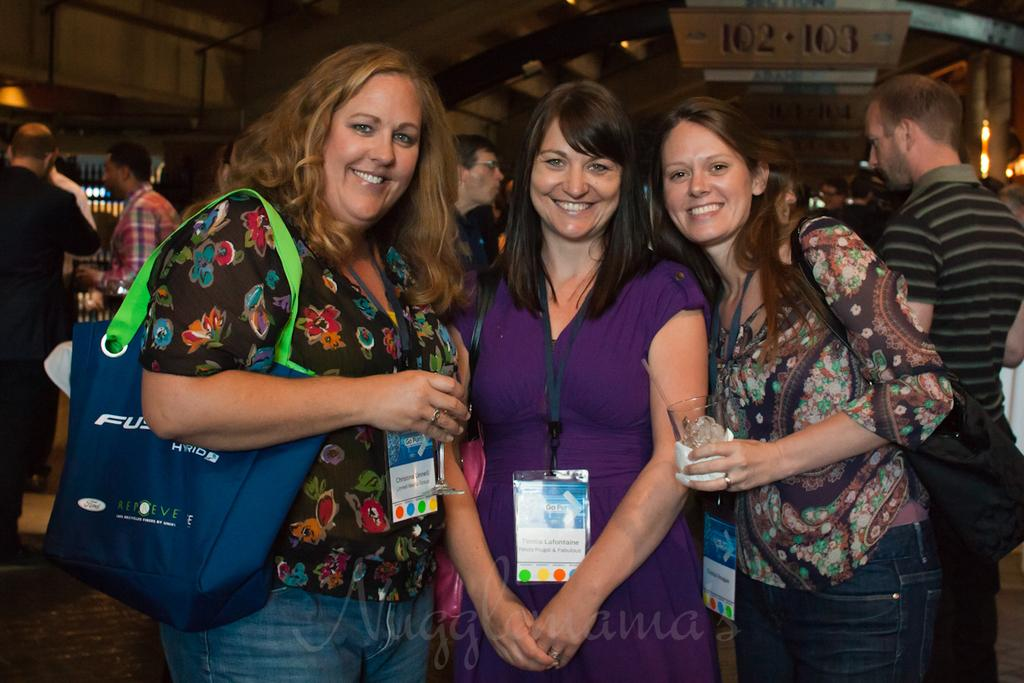What is happening in the image? There are people standing in the image. Can you describe the woman on the left side? The woman on the left side is carrying a bag. What can be seen in the background of the image? There are boards visible in the background of the image. What is the source of illumination in the image? There is a light in the image. What type of monkey is sitting on the woman's shoulder in the image? There is no monkey present in the image. What season is depicted in the image? The provided facts do not mention any seasonal details, so it cannot be determined from the image. 